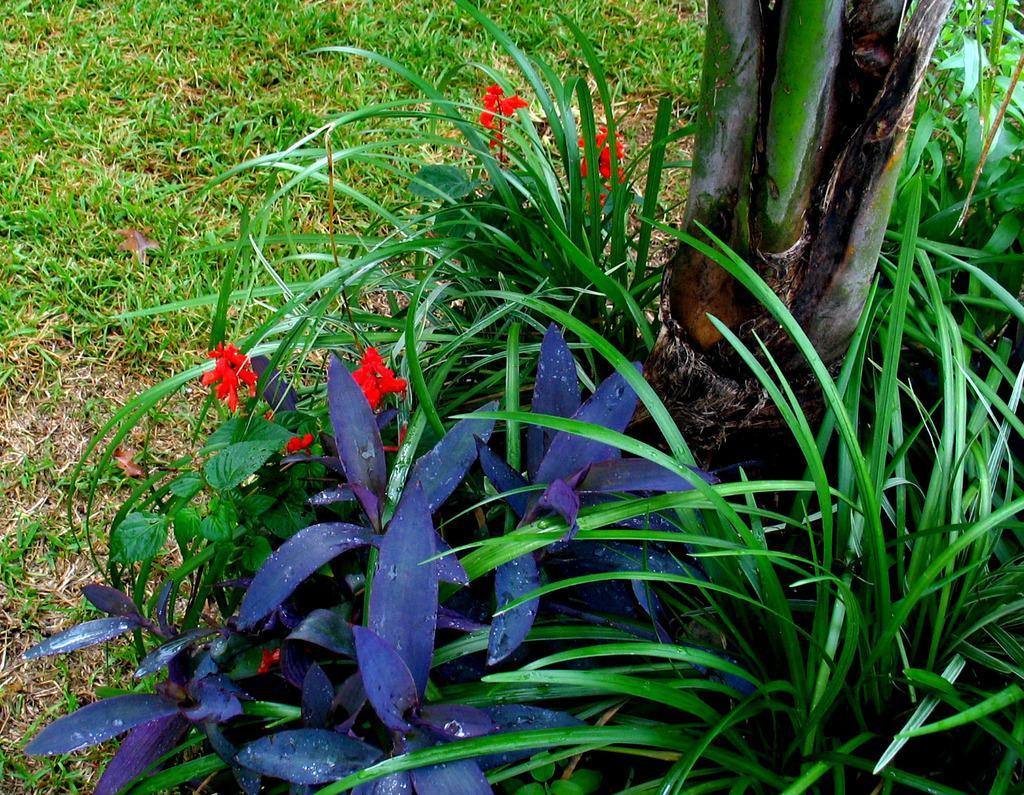In one or two sentences, can you explain what this image depicts? In this image in the foreground there are some plans and flowers, and in the background there is grass and on the right side there is one tree. 